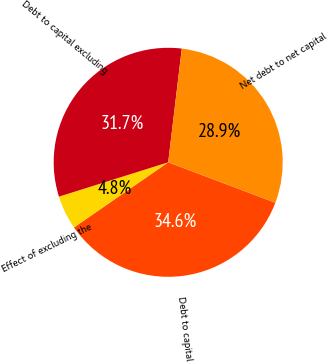Convert chart. <chart><loc_0><loc_0><loc_500><loc_500><pie_chart><fcel>Debt to capital<fcel>Effect of excluding the<fcel>Debt to capital excluding<fcel>Net debt to net capital<nl><fcel>34.63%<fcel>4.78%<fcel>31.74%<fcel>28.85%<nl></chart> 